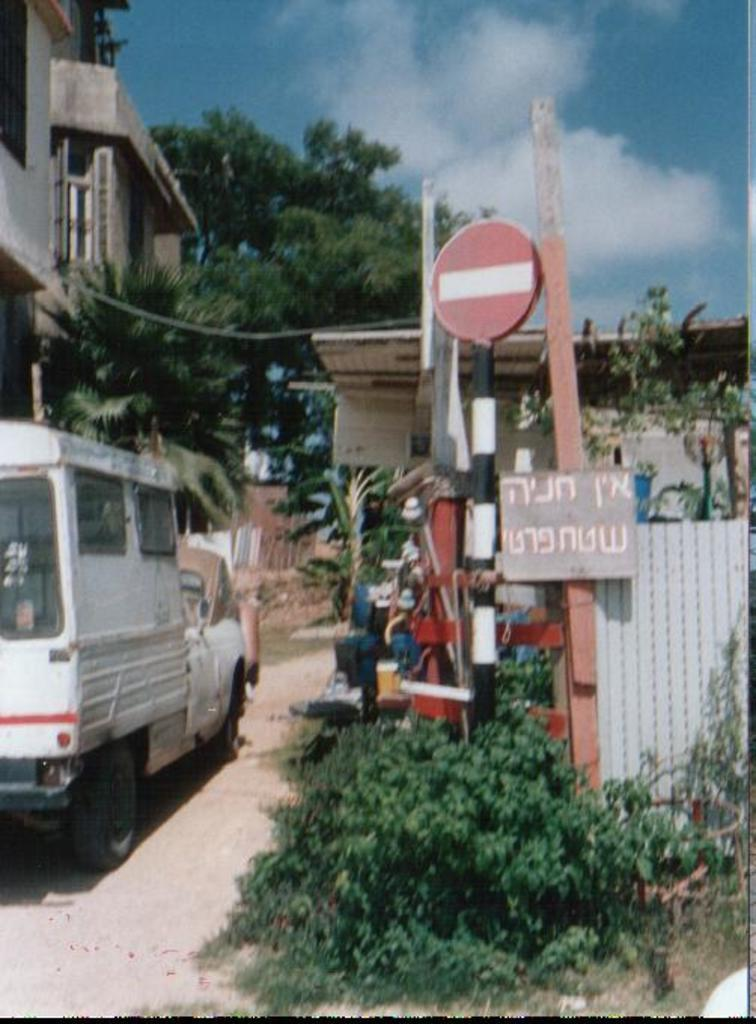What is the main subject of the image? There is a vehicle on the road in the image. What else can be seen in the image besides the vehicle? There is a pole, a board, a plant, grass, a tree, and a building in the image. What is the condition of the sky in the image? The sky is cloudy in the image. Can you tell me how many streams are visible in the image? There are no streams visible in the image. What type of ornament is hanging from the tree in the image? There is no ornament hanging from the tree in the image; only the tree and other objects are present. 